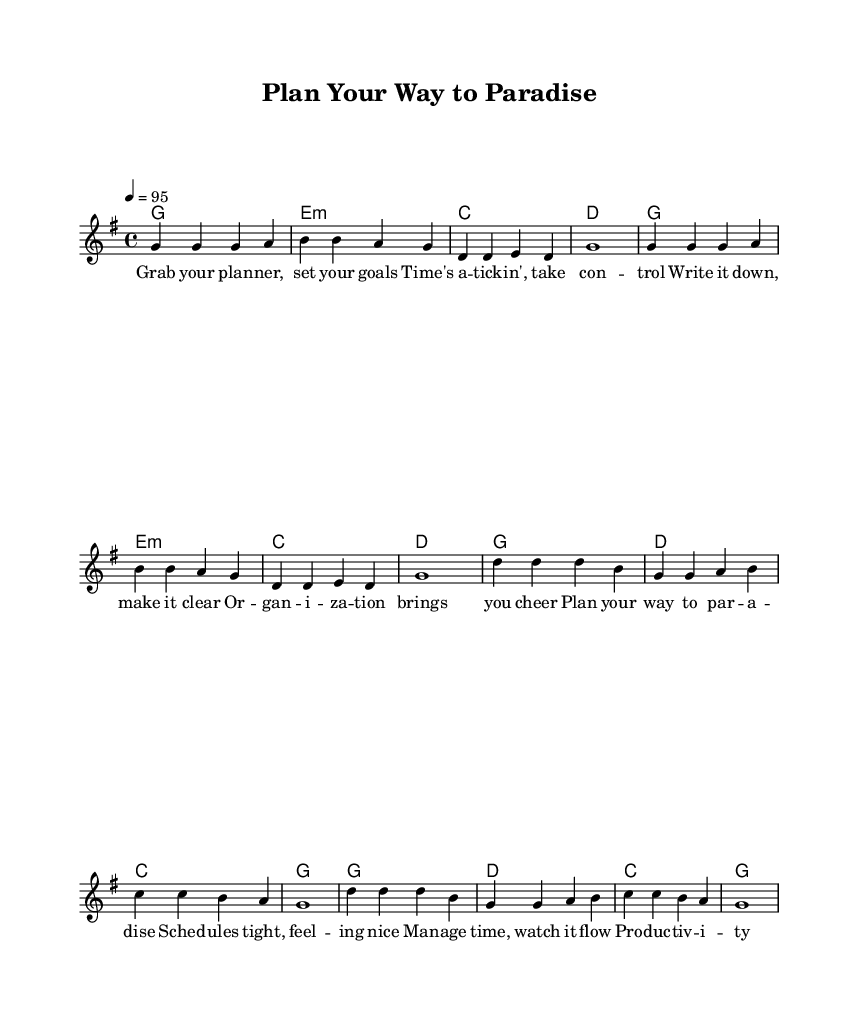What is the key signature of this music? The key signature indicates G major, which has one sharp (F#). This can be confirmed by looking at the initial key signature marking in the music sheet.
Answer: G major What is the time signature of this music? The time signature is indicated as 4/4, meaning there are four beats per measure and a quarter note gets one beat. This is visible in the early part of the music tax, typically placed at the beginning.
Answer: 4/4 What is the tempo of this music? The tempo marking is 4 = 95, suggesting a moderate speed of 95 beats per minute. This information is provided in the "tempo" section of the score.
Answer: 95 How many measures are in the verse? There are a total of 8 measures in the verse section of the music. This can be counted based on the grouping and separation of the music notes shown in the verse part.
Answer: 8 What are the first two chords of the verse? The first two chords of the verse are G and E minor. These can be found at the beginning of the chord names section corresponding to the verse's melody.
Answer: G, E minor What mood does this reggae fusion aim to create based on its lyrics? The lyrics depict themes of organization and productivity, invoking a positive and upbeat mood typical in reggae music that encourages action and self-management. This aligns with reggae’s common themes of positivity and upliftment.
Answer: Upbeat positivity What is the main theme of the chorus lyrics? The main theme of the chorus lyrics revolves around planning and time management, emphasizing feeling good and making productivity enjoyable. This can be deduced from the overall message conveyed in the chorus section of the lyrics.
Answer: Planning and time management 